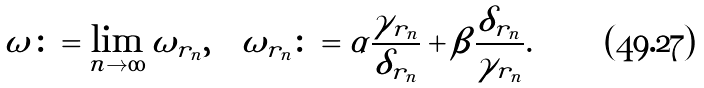Convert formula to latex. <formula><loc_0><loc_0><loc_500><loc_500>\omega \colon = \lim _ { n \to \infty } \omega _ { r _ { n } } , \quad \omega _ { r _ { n } } \colon = \alpha \frac { \gamma _ { r _ { n } } } { \delta _ { r _ { n } } } + \beta \frac { \delta _ { r _ { n } } } { \gamma _ { r _ { n } } } .</formula> 